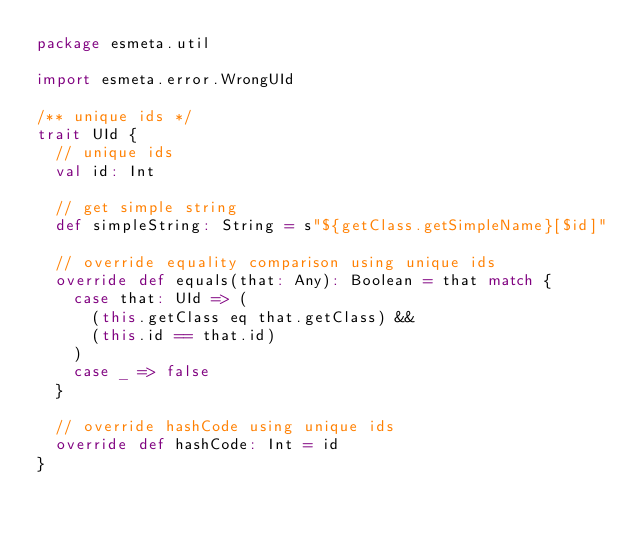<code> <loc_0><loc_0><loc_500><loc_500><_Scala_>package esmeta.util

import esmeta.error.WrongUId

/** unique ids */
trait UId {
  // unique ids
  val id: Int

  // get simple string
  def simpleString: String = s"${getClass.getSimpleName}[$id]"

  // override equality comparison using unique ids
  override def equals(that: Any): Boolean = that match {
    case that: UId => (
      (this.getClass eq that.getClass) &&
      (this.id == that.id)
    )
    case _ => false
  }

  // override hashCode using unique ids
  override def hashCode: Int = id
}
</code> 